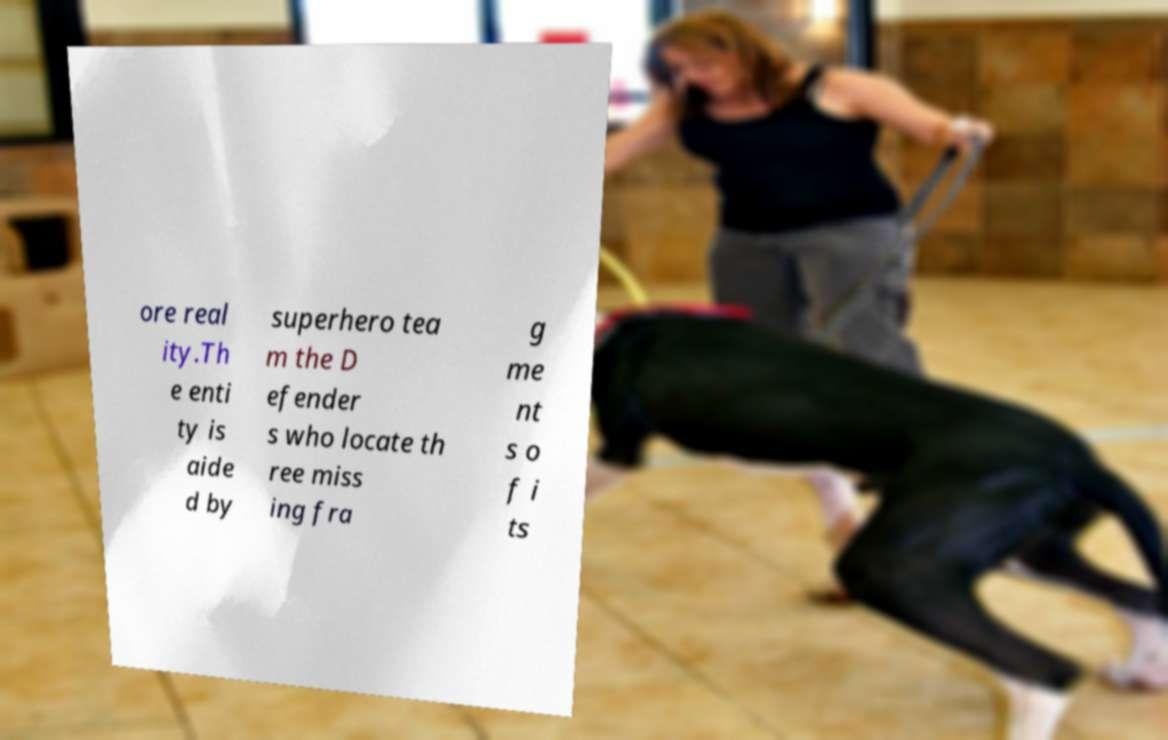Can you accurately transcribe the text from the provided image for me? ore real ity.Th e enti ty is aide d by superhero tea m the D efender s who locate th ree miss ing fra g me nt s o f i ts 